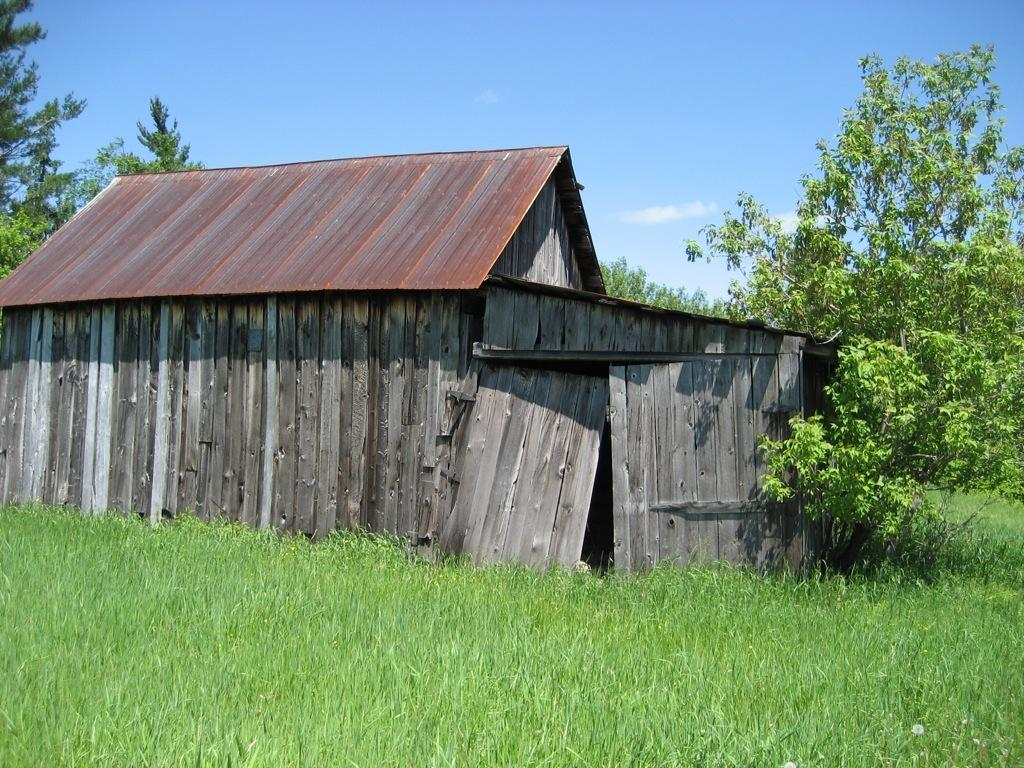What natural element is visible in the image? The sky is visible in the image. What can be seen in the sky in the image? Clouds are present in the image. What type of vegetation is visible in the image? Trees and grass are visible in the image. What type of structure is present in the image? There is a wooden house in the image. What type of quilt is draped over the trees in the image? There is no quilt present in the image; it features the sky, clouds, trees, grass, and a wooden house. How does the scene change when it starts raining in the image? The image does not depict rain, so it is not possible to describe how the scene would change in such a situation. 